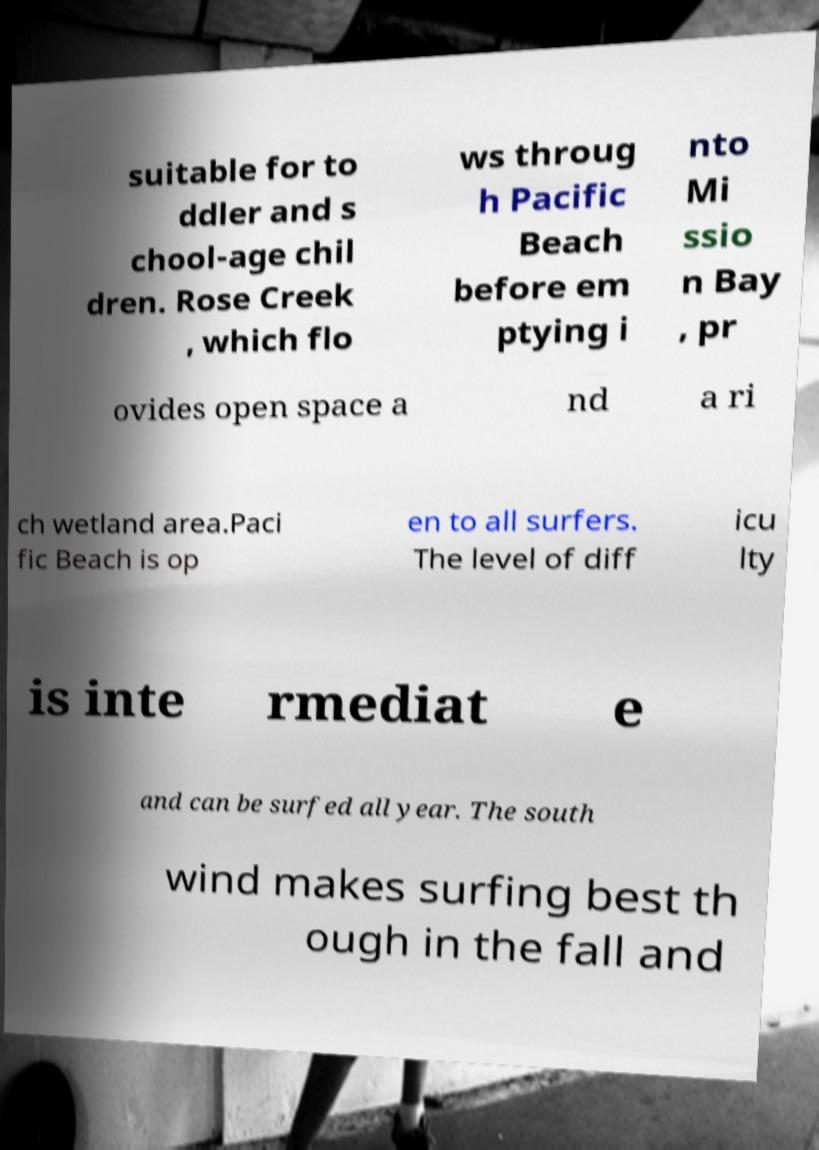For documentation purposes, I need the text within this image transcribed. Could you provide that? suitable for to ddler and s chool-age chil dren. Rose Creek , which flo ws throug h Pacific Beach before em ptying i nto Mi ssio n Bay , pr ovides open space a nd a ri ch wetland area.Paci fic Beach is op en to all surfers. The level of diff icu lty is inte rmediat e and can be surfed all year. The south wind makes surfing best th ough in the fall and 